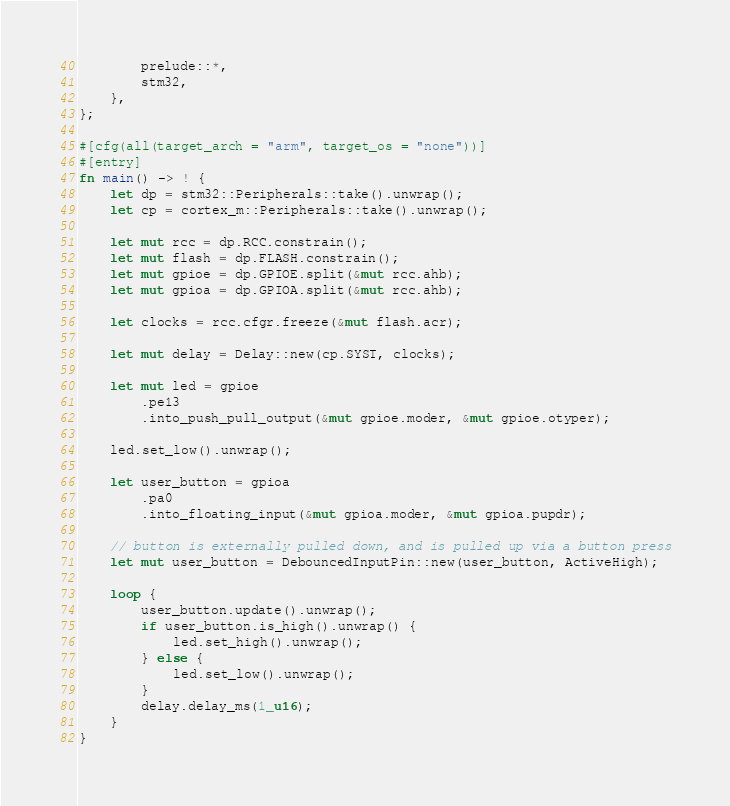Convert code to text. <code><loc_0><loc_0><loc_500><loc_500><_Rust_>        prelude::*,
        stm32,
    },
};

#[cfg(all(target_arch = "arm", target_os = "none"))]
#[entry]
fn main() -> ! {
    let dp = stm32::Peripherals::take().unwrap();
    let cp = cortex_m::Peripherals::take().unwrap();

    let mut rcc = dp.RCC.constrain();
    let mut flash = dp.FLASH.constrain();
    let mut gpioe = dp.GPIOE.split(&mut rcc.ahb);
    let mut gpioa = dp.GPIOA.split(&mut rcc.ahb);

    let clocks = rcc.cfgr.freeze(&mut flash.acr);

    let mut delay = Delay::new(cp.SYST, clocks);

    let mut led = gpioe
        .pe13
        .into_push_pull_output(&mut gpioe.moder, &mut gpioe.otyper);

    led.set_low().unwrap();

    let user_button = gpioa
        .pa0
        .into_floating_input(&mut gpioa.moder, &mut gpioa.pupdr);

    // button is externally pulled down, and is pulled up via a button press
    let mut user_button = DebouncedInputPin::new(user_button, ActiveHigh);

    loop {
        user_button.update().unwrap();
        if user_button.is_high().unwrap() {
            led.set_high().unwrap();
        } else {
            led.set_low().unwrap();
        }
        delay.delay_ms(1_u16);
    }
}
</code> 